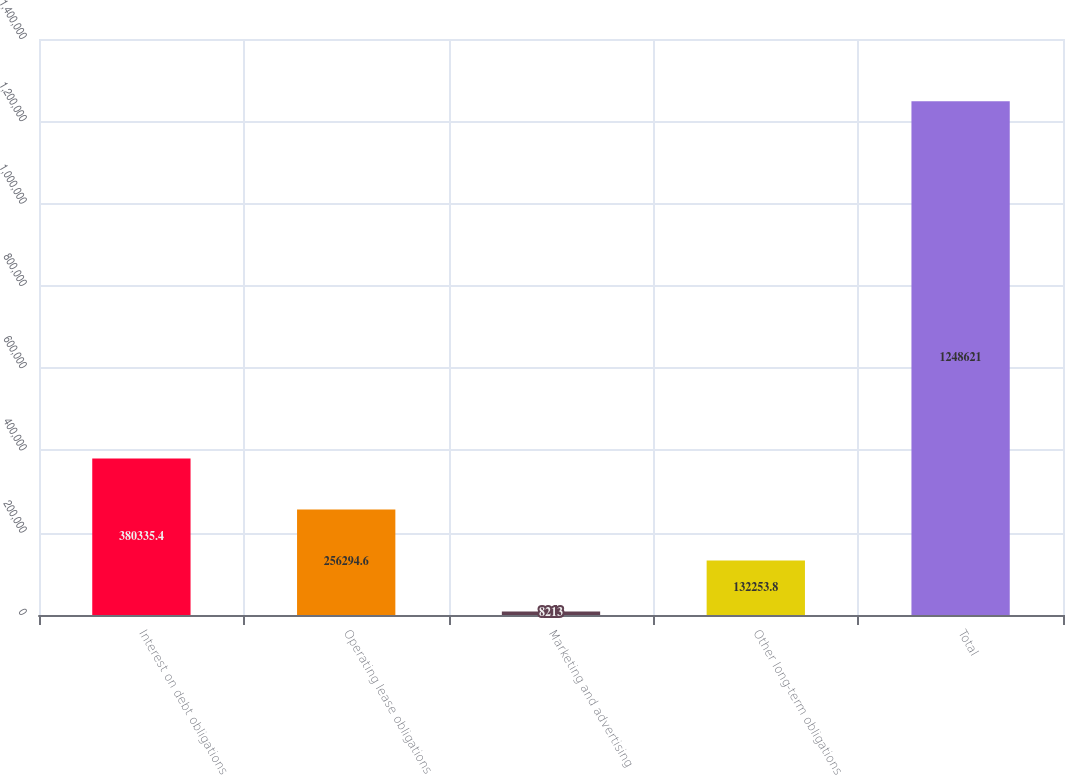Convert chart. <chart><loc_0><loc_0><loc_500><loc_500><bar_chart><fcel>Interest on debt obligations<fcel>Operating lease obligations<fcel>Marketing and advertising<fcel>Other long-term obligations<fcel>Total<nl><fcel>380335<fcel>256295<fcel>8213<fcel>132254<fcel>1.24862e+06<nl></chart> 